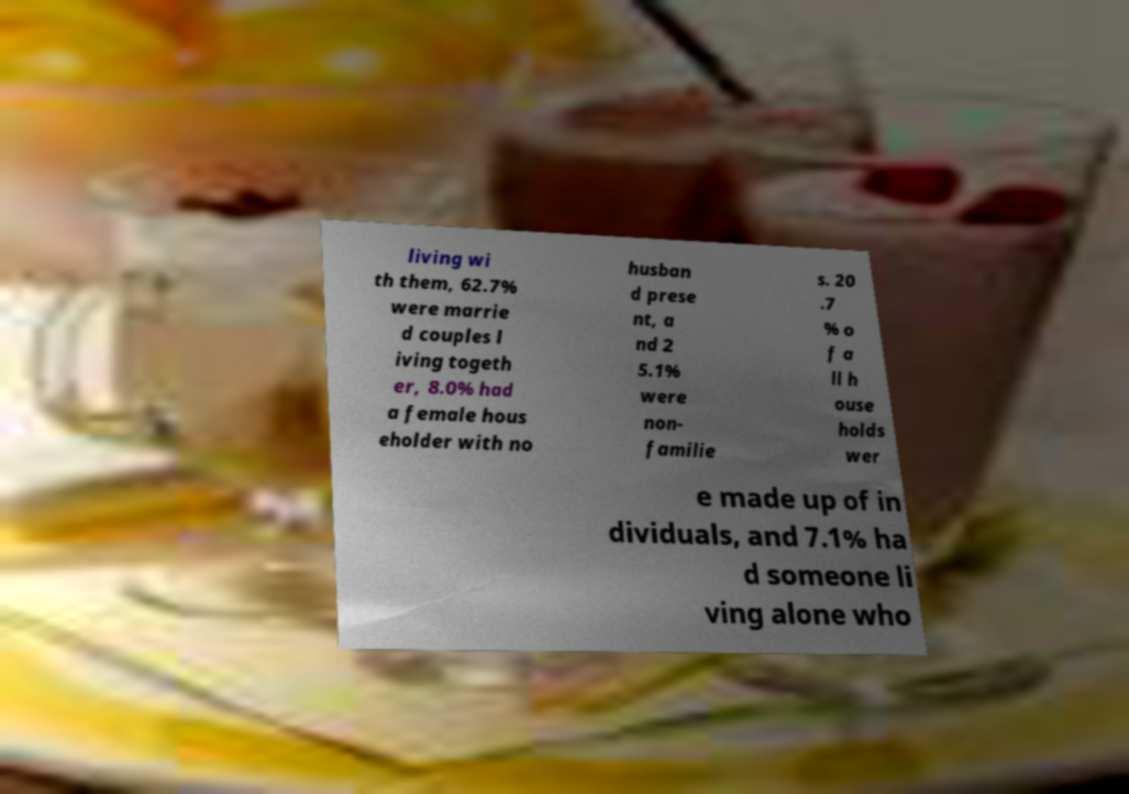Could you assist in decoding the text presented in this image and type it out clearly? living wi th them, 62.7% were marrie d couples l iving togeth er, 8.0% had a female hous eholder with no husban d prese nt, a nd 2 5.1% were non- familie s. 20 .7 % o f a ll h ouse holds wer e made up of in dividuals, and 7.1% ha d someone li ving alone who 